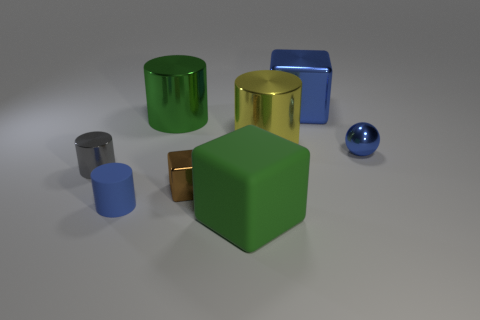Subtract all large metal blocks. How many blocks are left? 2 Subtract all blue cylinders. How many cylinders are left? 3 Subtract all spheres. How many objects are left? 7 Subtract all gray cubes. How many green balls are left? 0 Add 2 tiny blue cylinders. How many objects exist? 10 Subtract all blue cylinders. Subtract all large cylinders. How many objects are left? 5 Add 8 yellow shiny things. How many yellow shiny things are left? 9 Add 6 tiny shiny cylinders. How many tiny shiny cylinders exist? 7 Subtract 0 green balls. How many objects are left? 8 Subtract 3 cylinders. How many cylinders are left? 1 